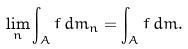Convert formula to latex. <formula><loc_0><loc_0><loc_500><loc_500>\lim _ { n } \int _ { A } f \, d m _ { n } = \int _ { A } f \, d m .</formula> 